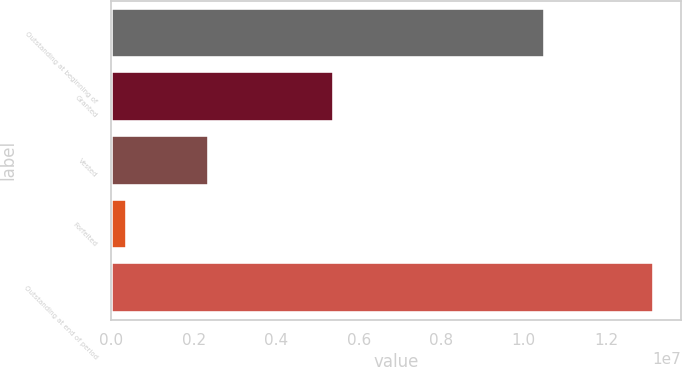Convert chart. <chart><loc_0><loc_0><loc_500><loc_500><bar_chart><fcel>Outstanding at beginning of<fcel>Granted<fcel>Vested<fcel>Forfeited<fcel>Outstanding at end of period<nl><fcel>1.05183e+07<fcel>5.38948e+06<fcel>2.37119e+06<fcel>382022<fcel>1.31546e+07<nl></chart> 